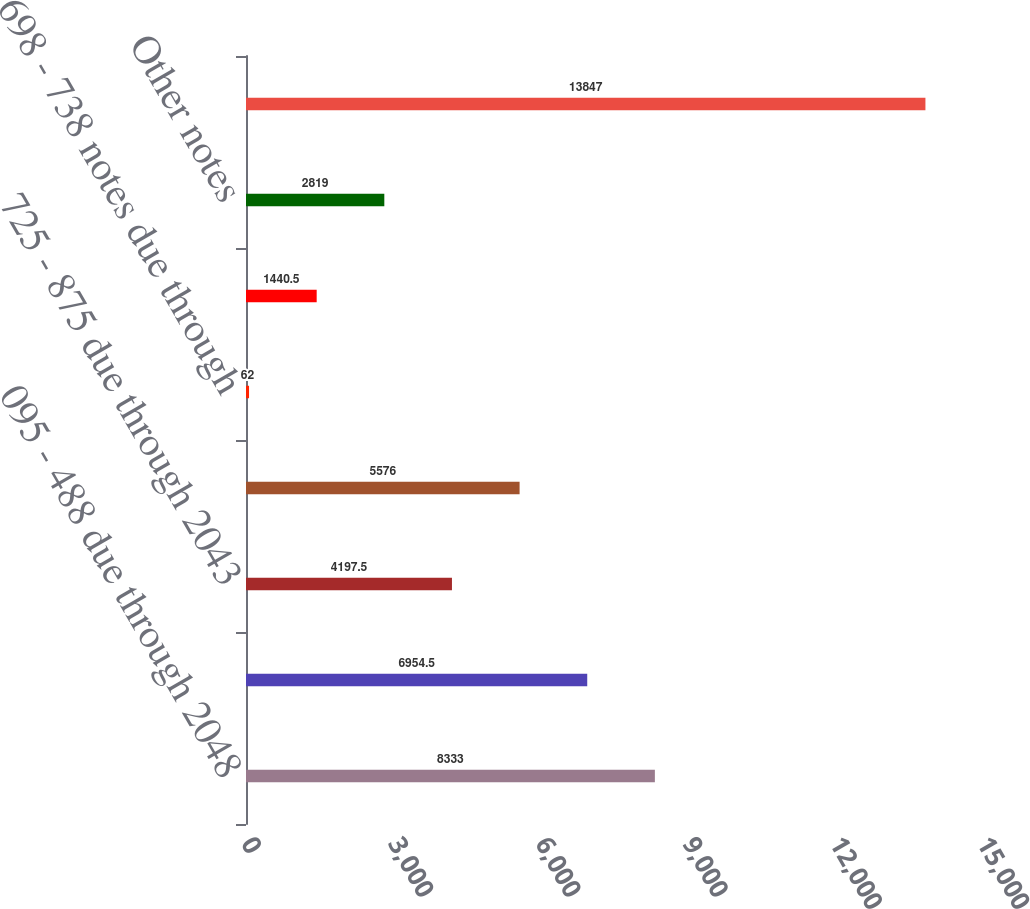Convert chart. <chart><loc_0><loc_0><loc_500><loc_500><bar_chart><fcel>095 - 488 due through 2048<fcel>580 - 688 due through 2043<fcel>725 - 875 due through 2043<fcel>Commercial paper<fcel>698 - 738 notes due through<fcel>Capital lease obligations due<fcel>Other notes<fcel>Total debt<nl><fcel>8333<fcel>6954.5<fcel>4197.5<fcel>5576<fcel>62<fcel>1440.5<fcel>2819<fcel>13847<nl></chart> 